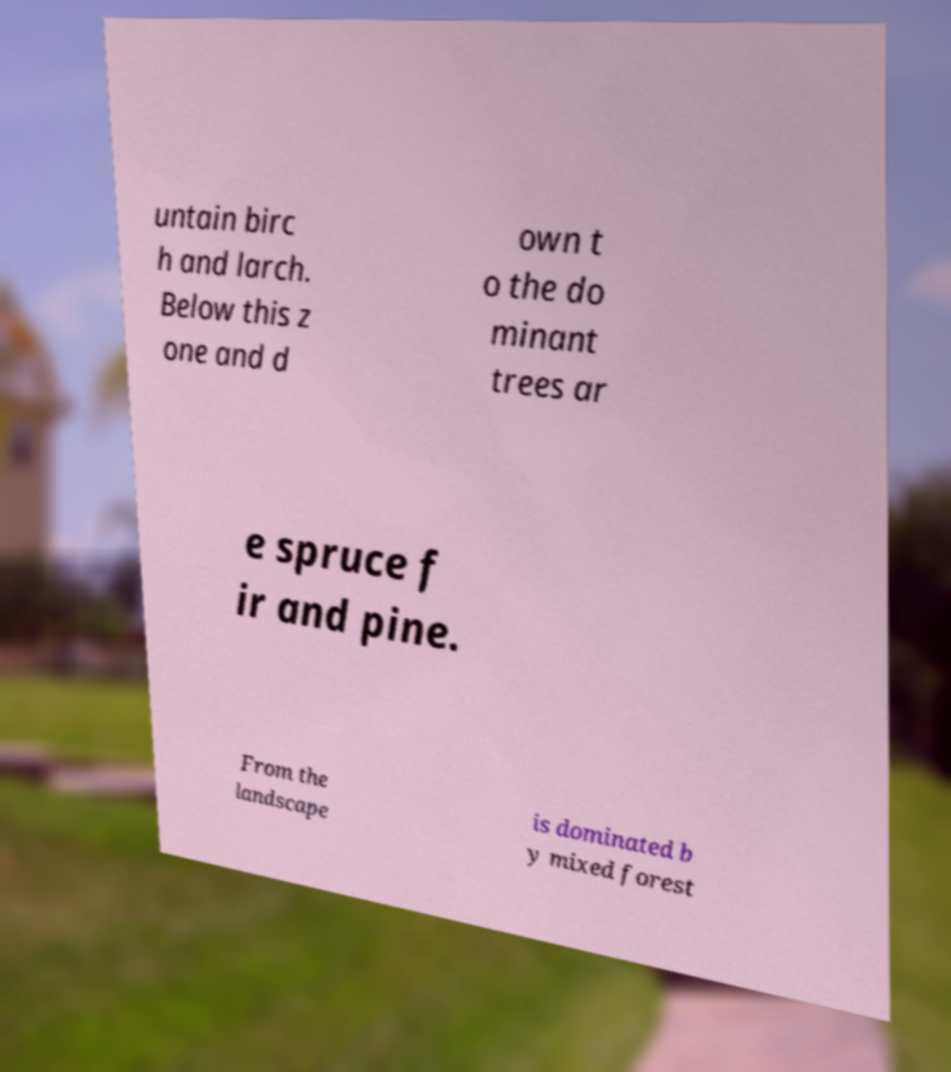There's text embedded in this image that I need extracted. Can you transcribe it verbatim? untain birc h and larch. Below this z one and d own t o the do minant trees ar e spruce f ir and pine. From the landscape is dominated b y mixed forest 